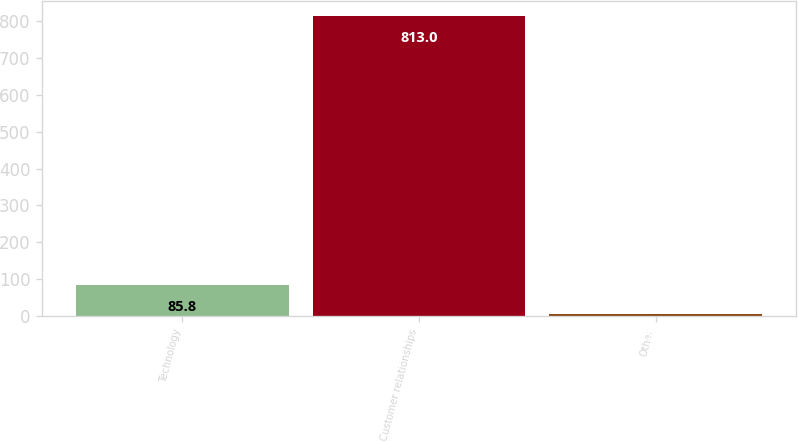Convert chart to OTSL. <chart><loc_0><loc_0><loc_500><loc_500><bar_chart><fcel>Technology<fcel>Customer relationships<fcel>Other<nl><fcel>85.8<fcel>813<fcel>5<nl></chart> 